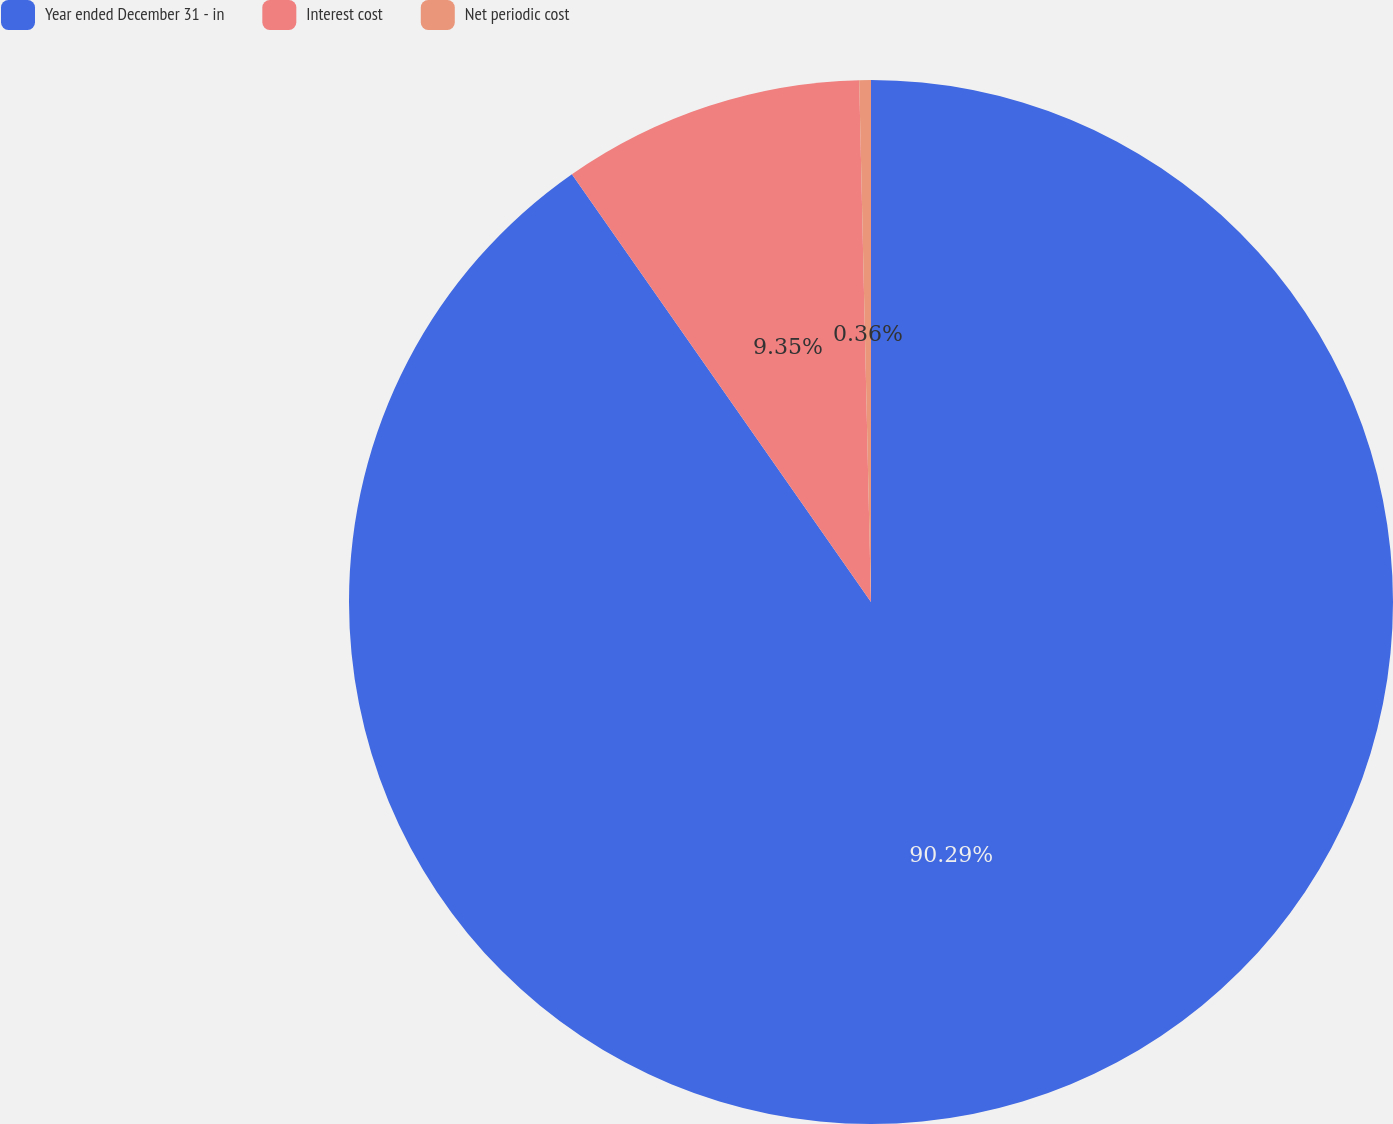Convert chart to OTSL. <chart><loc_0><loc_0><loc_500><loc_500><pie_chart><fcel>Year ended December 31 - in<fcel>Interest cost<fcel>Net periodic cost<nl><fcel>90.29%<fcel>9.35%<fcel>0.36%<nl></chart> 